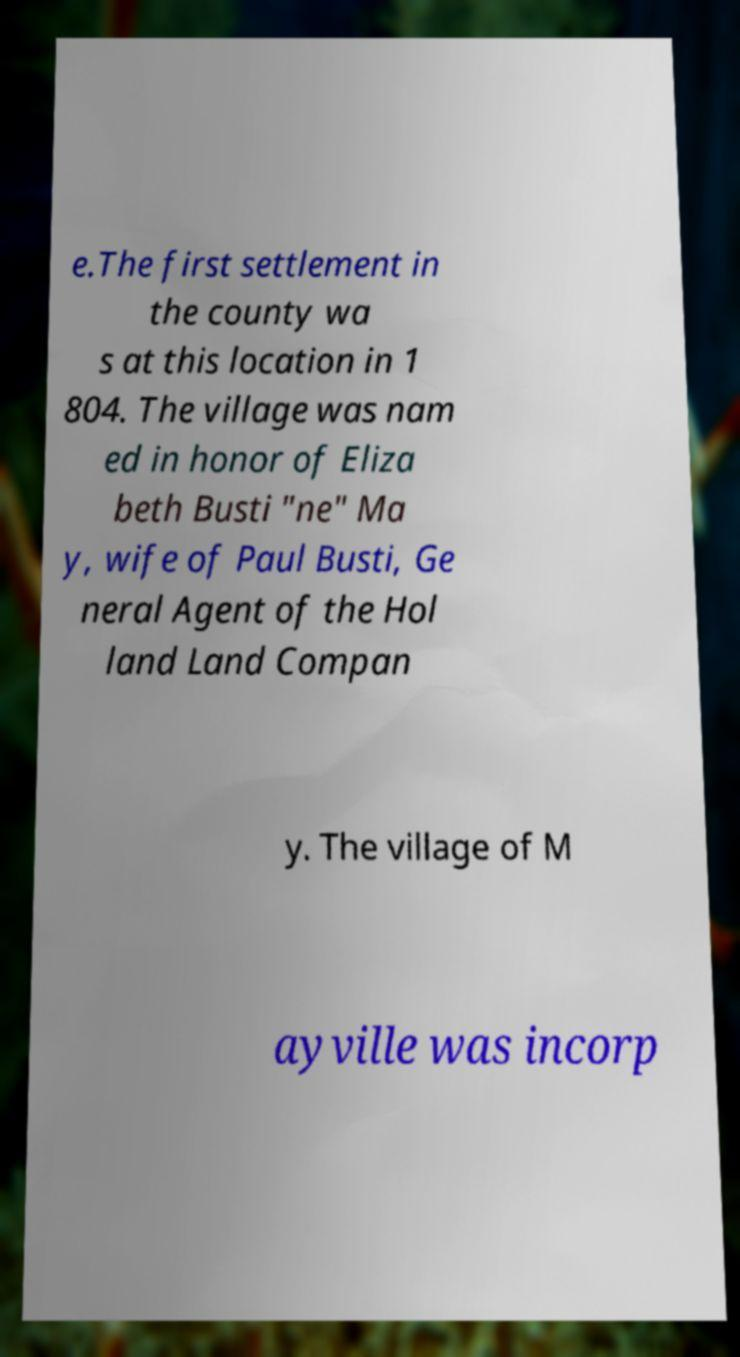Can you read and provide the text displayed in the image?This photo seems to have some interesting text. Can you extract and type it out for me? e.The first settlement in the county wa s at this location in 1 804. The village was nam ed in honor of Eliza beth Busti "ne" Ma y, wife of Paul Busti, Ge neral Agent of the Hol land Land Compan y. The village of M ayville was incorp 